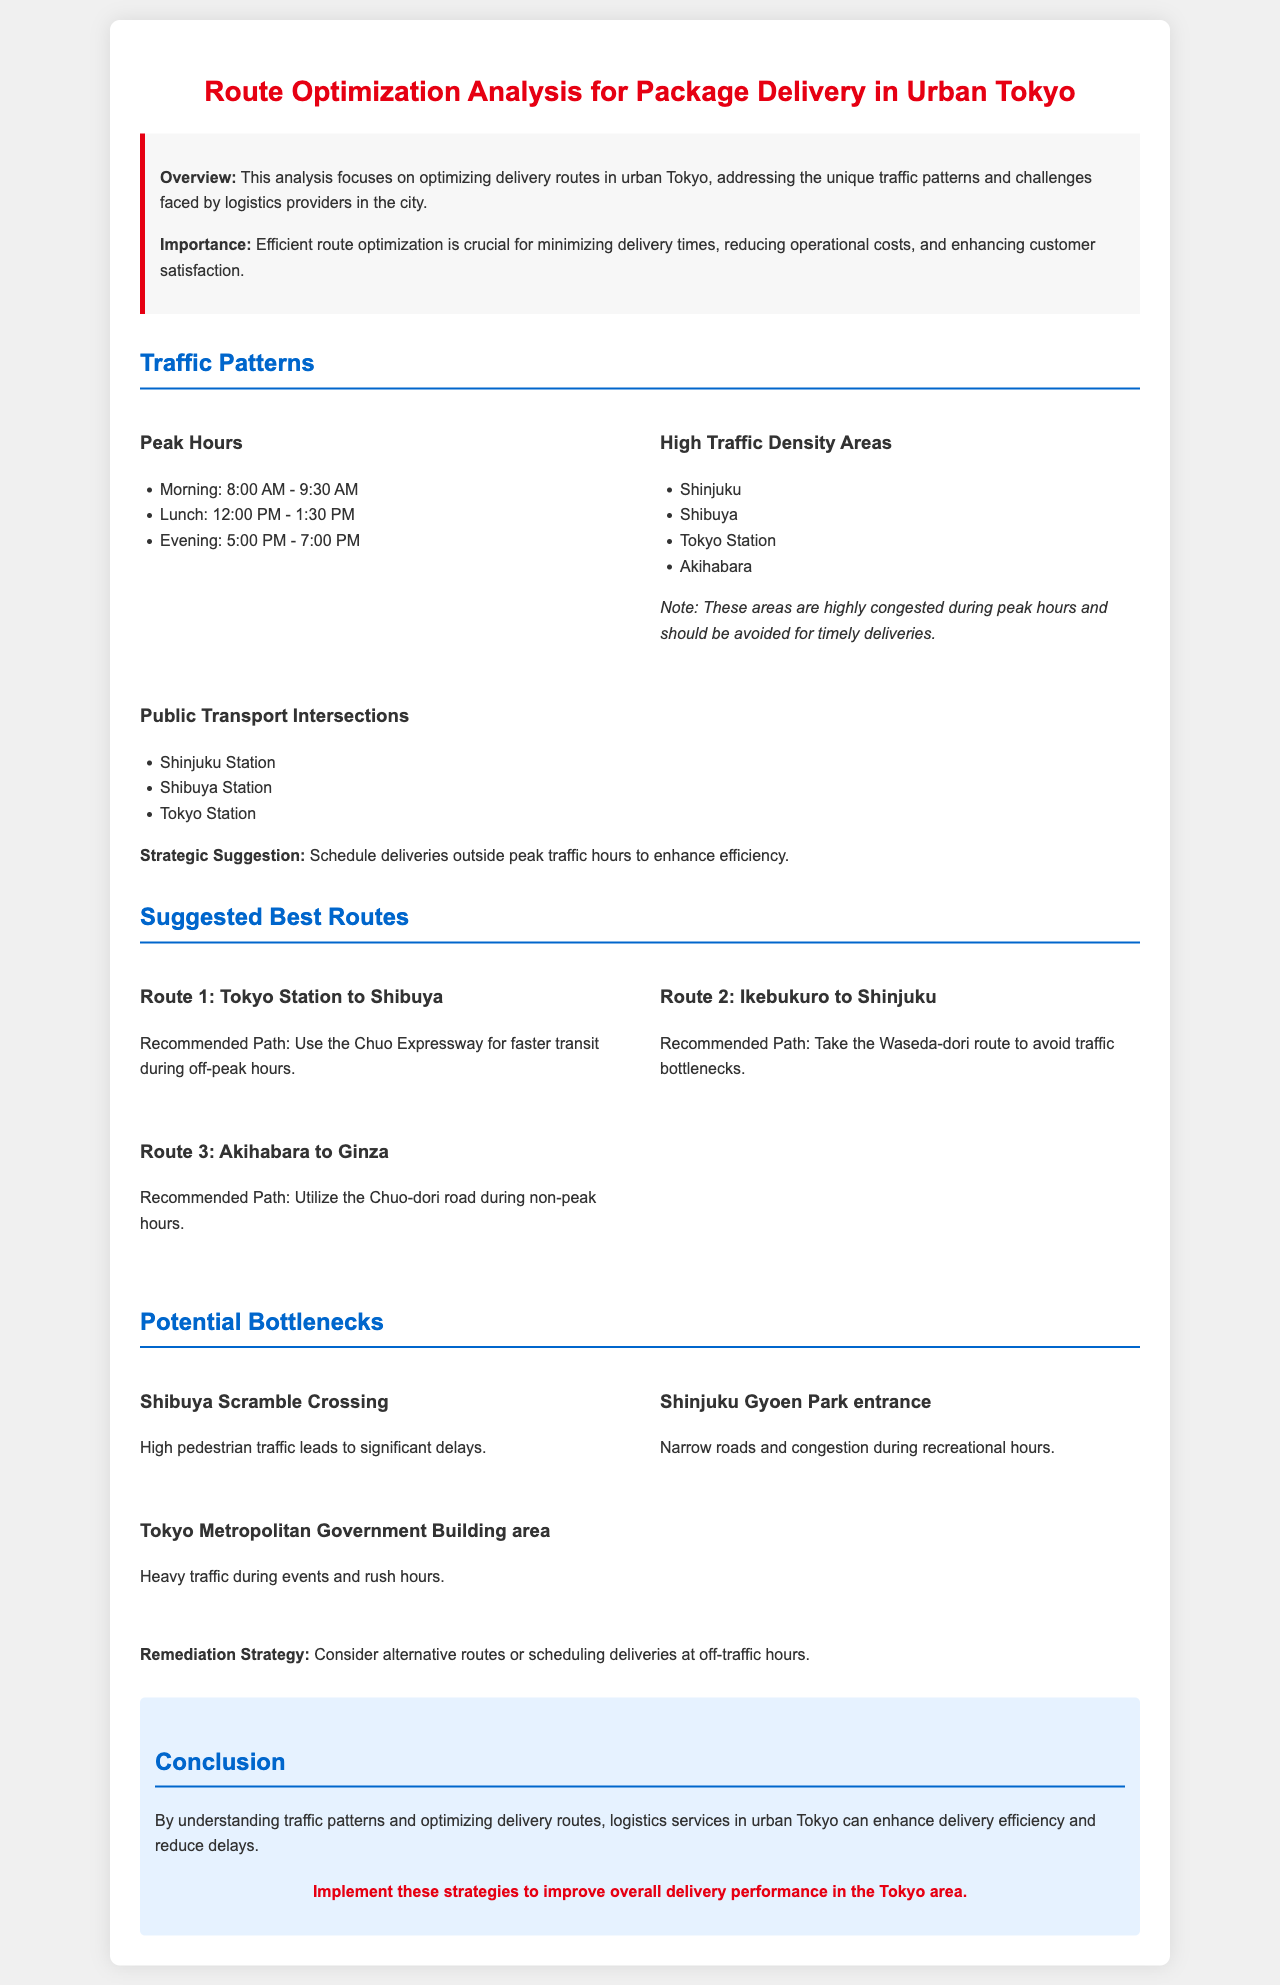What are the peak morning hours? The document lists the morning peak hours as 8:00 AM - 9:30 AM.
Answer: 8:00 AM - 9:30 AM What area is known for high traffic density? The document mentions areas like Shinjuku, Shibuya, Tokyo Station, and Akihabara as high traffic density areas.
Answer: Shinjuku What is the recommended path from Tokyo Station to Shibuya? The document suggests using the Chuo Expressway for faster transit during off-peak hours.
Answer: Chuo Expressway Which location is a potential bottleneck due to high pedestrian traffic? The document specifically mentions Shibuya Scramble Crossing as a location with significant delays due to high pedestrian traffic.
Answer: Shibuya Scramble Crossing What is the remediation strategy for potential bottlenecks? The document recommends considering alternative routes or scheduling deliveries at off-traffic hours as a remediation strategy.
Answer: Alternative routes or scheduling deliveries at off-traffic hours What is the purpose of this analysis? The document states that the purpose is to optimize delivery routes in urban Tokyo, addressing unique traffic patterns and challenges.
Answer: Optimize delivery routes Which station is noted for being a public transport intersection? The document lists Shinjuku Station as one of the public transport intersections.
Answer: Shinjuku Station What is the conclusion of the analysis? The conclusion states that understanding traffic patterns and optimizing delivery routes can enhance delivery efficiency and reduce delays.
Answer: Enhance delivery efficiency and reduce delays 